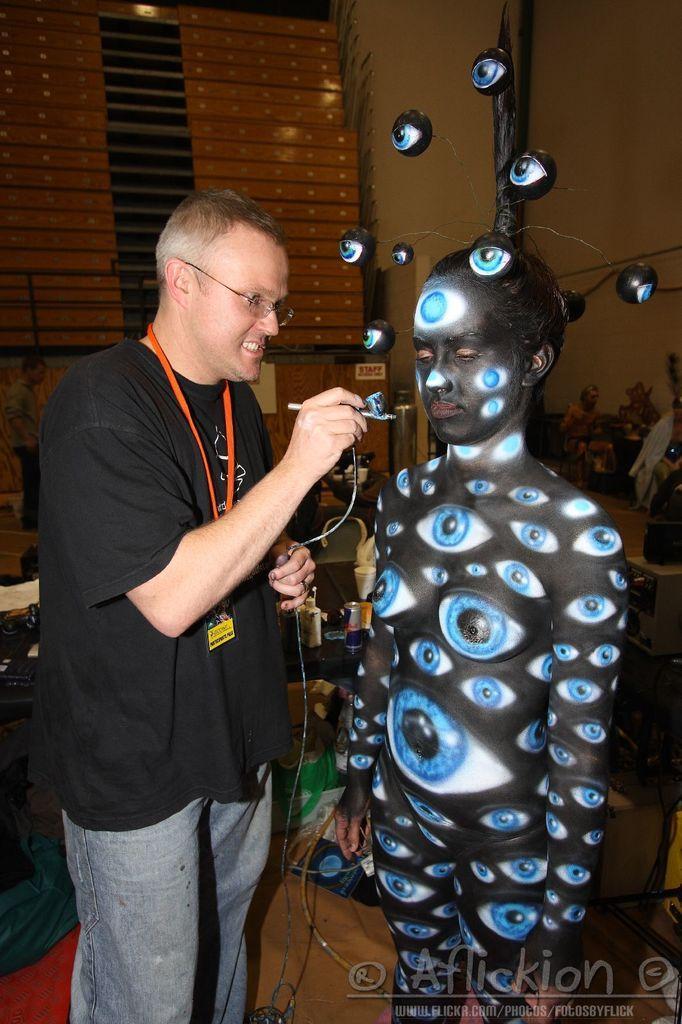Please provide a concise description of this image. In this picture I can observe two persons. One of them is wearing black color T shirt and and orange color tag in his neck. One of the persons is painting the other person with black and blue colors. I can observe eyes painted on the other person. In the background there is a wall. 